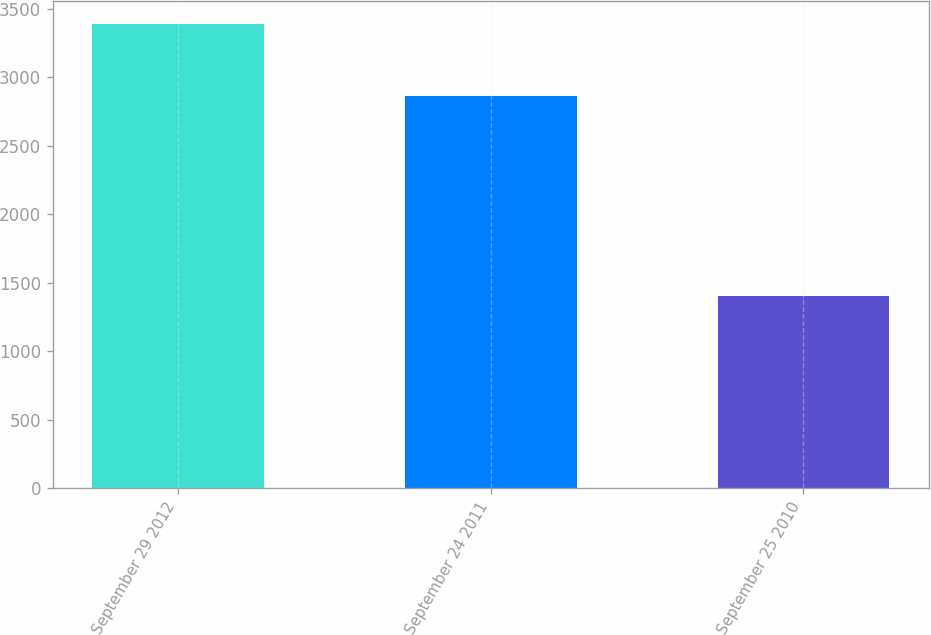Convert chart. <chart><loc_0><loc_0><loc_500><loc_500><bar_chart><fcel>September 29 2012<fcel>September 24 2011<fcel>September 25 2010<nl><fcel>3390<fcel>2867<fcel>1405<nl></chart> 